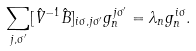Convert formula to latex. <formula><loc_0><loc_0><loc_500><loc_500>\sum _ { j , \sigma ^ { \prime } } [ \hat { V } ^ { - 1 } \hat { B } ] _ { i \sigma , j \sigma ^ { \prime } } g _ { n } ^ { j \sigma ^ { \prime } } = \lambda _ { n } g _ { n } ^ { i \sigma } .</formula> 